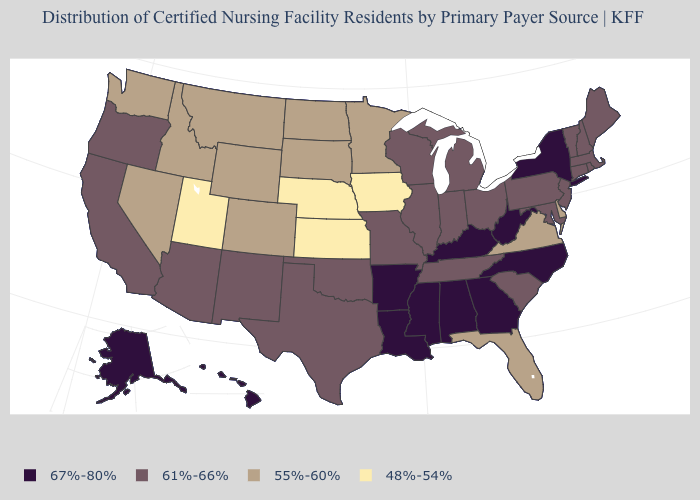What is the lowest value in states that border Texas?
Be succinct. 61%-66%. Which states have the lowest value in the South?
Write a very short answer. Delaware, Florida, Virginia. What is the value of Kansas?
Answer briefly. 48%-54%. What is the value of Massachusetts?
Be succinct. 61%-66%. What is the value of Delaware?
Give a very brief answer. 55%-60%. Among the states that border Minnesota , which have the lowest value?
Keep it brief. Iowa. Name the states that have a value in the range 67%-80%?
Give a very brief answer. Alabama, Alaska, Arkansas, Georgia, Hawaii, Kentucky, Louisiana, Mississippi, New York, North Carolina, West Virginia. Does Nebraska have the lowest value in the USA?
Quick response, please. Yes. Does Ohio have a higher value than Kentucky?
Be succinct. No. What is the highest value in states that border Maryland?
Keep it brief. 67%-80%. Does California have the highest value in the West?
Short answer required. No. Does the map have missing data?
Keep it brief. No. Which states have the highest value in the USA?
Be succinct. Alabama, Alaska, Arkansas, Georgia, Hawaii, Kentucky, Louisiana, Mississippi, New York, North Carolina, West Virginia. Which states have the highest value in the USA?
Keep it brief. Alabama, Alaska, Arkansas, Georgia, Hawaii, Kentucky, Louisiana, Mississippi, New York, North Carolina, West Virginia. What is the highest value in the USA?
Give a very brief answer. 67%-80%. 